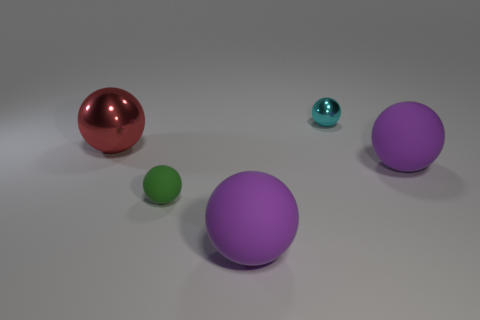Subtract all tiny cyan balls. How many balls are left? 4 Subtract all green blocks. How many purple spheres are left? 2 Subtract all cyan balls. How many balls are left? 4 Add 3 brown matte cylinders. How many objects exist? 8 Subtract all brown balls. Subtract all green blocks. How many balls are left? 5 Add 1 large brown matte balls. How many large brown matte balls exist? 1 Subtract 0 brown balls. How many objects are left? 5 Subtract all small cyan objects. Subtract all purple matte spheres. How many objects are left? 2 Add 4 green rubber balls. How many green rubber balls are left? 5 